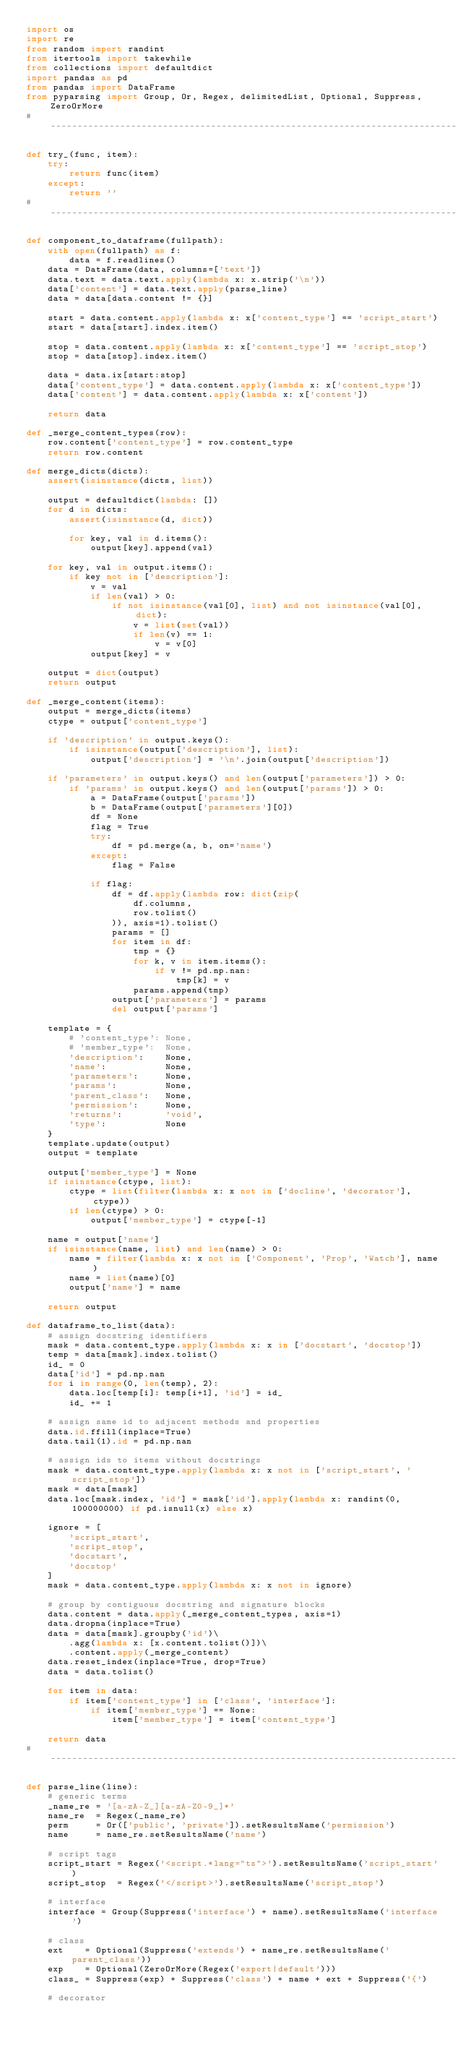<code> <loc_0><loc_0><loc_500><loc_500><_Python_>import os
import re
from random import randint
from itertools import takewhile
from collections import defaultdict
import pandas as pd
from pandas import DataFrame
from pyparsing import Group, Or, Regex, delimitedList, Optional, Suppress, ZeroOrMore
# ------------------------------------------------------------------------------

def try_(func, item):
    try:
        return func(item)
    except:
        return ''
# ------------------------------------------------------------------------------

def component_to_dataframe(fullpath):
    with open(fullpath) as f:
        data = f.readlines()
    data = DataFrame(data, columns=['text'])
    data.text = data.text.apply(lambda x: x.strip('\n'))
    data['content'] = data.text.apply(parse_line)
    data = data[data.content != {}]

    start = data.content.apply(lambda x: x['content_type'] == 'script_start')
    start = data[start].index.item()

    stop = data.content.apply(lambda x: x['content_type'] == 'script_stop')
    stop = data[stop].index.item()

    data = data.ix[start:stop]
    data['content_type'] = data.content.apply(lambda x: x['content_type'])
    data['content'] = data.content.apply(lambda x: x['content'])

    return data

def _merge_content_types(row):
    row.content['content_type'] = row.content_type
    return row.content

def merge_dicts(dicts):
    assert(isinstance(dicts, list))

    output = defaultdict(lambda: [])
    for d in dicts:
        assert(isinstance(d, dict))

        for key, val in d.items():
            output[key].append(val)

    for key, val in output.items():
        if key not in ['description']:
            v = val
            if len(val) > 0:
                if not isinstance(val[0], list) and not isinstance(val[0], dict):
                    v = list(set(val))
                    if len(v) == 1:
                        v = v[0]
            output[key] = v

    output = dict(output)
    return output

def _merge_content(items):
    output = merge_dicts(items)
    ctype = output['content_type']

    if 'description' in output.keys():
        if isinstance(output['description'], list):
            output['description'] = '\n'.join(output['description'])

    if 'parameters' in output.keys() and len(output['parameters']) > 0:
        if 'params' in output.keys() and len(output['params']) > 0:
            a = DataFrame(output['params'])
            b = DataFrame(output['parameters'][0])
            df = None
            flag = True
            try:
                df = pd.merge(a, b, on='name')
            except:
                flag = False

            if flag:
                df = df.apply(lambda row: dict(zip(
                    df.columns,
                    row.tolist()
                )), axis=1).tolist()
                params = []
                for item in df:
                    tmp = {}
                    for k, v in item.items():
                        if v != pd.np.nan:
                            tmp[k] = v
                    params.append(tmp)
                output['parameters'] = params
                del output['params']

    template = {
        # 'content_type': None,
        # 'member_type':  None,
        'description':    None,
        'name':           None,
        'parameters':     None,
        'params':         None,
        'parent_class':   None,
        'permission':     None,
        'returns':        'void',
        'type':           None
    }
    template.update(output)
    output = template

    output['member_type'] = None
    if isinstance(ctype, list):
        ctype = list(filter(lambda x: x not in ['docline', 'decorator'], ctype))
        if len(ctype) > 0:
            output['member_type'] = ctype[-1]

    name = output['name']
    if isinstance(name, list) and len(name) > 0:
        name = filter(lambda x: x not in ['Component', 'Prop', 'Watch'], name)
        name = list(name)[0]
        output['name'] = name

    return output

def dataframe_to_list(data):
    # assign docstring identifiers
    mask = data.content_type.apply(lambda x: x in ['docstart', 'docstop'])
    temp = data[mask].index.tolist()
    id_ = 0
    data['id'] = pd.np.nan
    for i in range(0, len(temp), 2):
        data.loc[temp[i]: temp[i+1], 'id'] = id_
        id_ += 1

    # assign same id to adjacent methods and properties
    data.id.ffill(inplace=True)
    data.tail(1).id = pd.np.nan

    # assign ids to items without docstrings
    mask = data.content_type.apply(lambda x: x not in ['script_start', 'script_stop'])
    mask = data[mask]
    data.loc[mask.index, 'id'] = mask['id'].apply(lambda x: randint(0, 100000000) if pd.isnull(x) else x)

    ignore = [
        'script_start',
        'script_stop',
        'docstart',
        'docstop'
    ]
    mask = data.content_type.apply(lambda x: x not in ignore)

    # group by contiguous docstring and signature blocks
    data.content = data.apply(_merge_content_types, axis=1)
    data.dropna(inplace=True)
    data = data[mask].groupby('id')\
        .agg(lambda x: [x.content.tolist()])\
        .content.apply(_merge_content)
    data.reset_index(inplace=True, drop=True)
    data = data.tolist()

    for item in data:
        if item['content_type'] in ['class', 'interface']:
            if item['member_type'] == None:
                item['member_type'] = item['content_type']

    return data
# ------------------------------------------------------------------------------

def parse_line(line):
    # generic terms
    _name_re = '[a-zA-Z_][a-zA-Z0-9_]*'
    name_re  = Regex(_name_re)
    perm     = Or(['public', 'private']).setResultsName('permission')
    name     = name_re.setResultsName('name')

    # script tags
    script_start = Regex('<script.*lang="ts">').setResultsName('script_start')
    script_stop  = Regex('</script>').setResultsName('script_stop')

    # interface
    interface = Group(Suppress('interface') + name).setResultsName('interface')

    # class
    ext    = Optional(Suppress('extends') + name_re.setResultsName('parent_class'))
    exp    = Optional(ZeroOrMore(Regex('export|default')))
    class_ = Suppress(exp) + Suppress('class') + name + ext + Suppress('{')

    # decorator</code> 